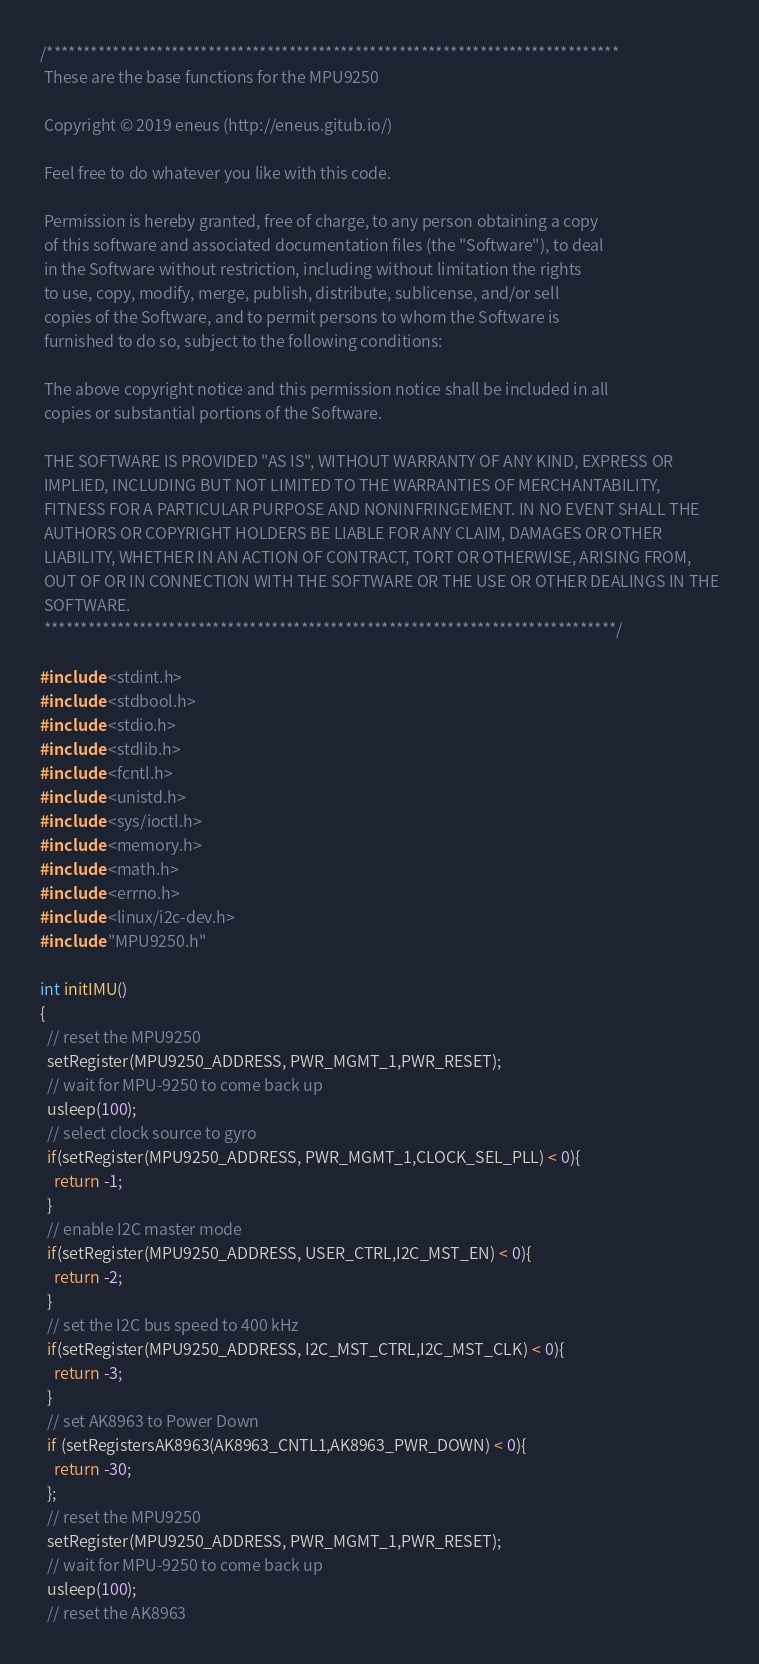Convert code to text. <code><loc_0><loc_0><loc_500><loc_500><_C_>/******************************************************************************
 These are the base functions for the MPU9250

 Copyright © 2019 eneus (http://eneus.gitub.io/)

 Feel free to do whatever you like with this code.

 Permission is hereby granted, free of charge, to any person obtaining a copy
 of this software and associated documentation files (the "Software"), to deal
 in the Software without restriction, including without limitation the rights
 to use, copy, modify, merge, publish, distribute, sublicense, and/or sell
 copies of the Software, and to permit persons to whom the Software is
 furnished to do so, subject to the following conditions:

 The above copyright notice and this permission notice shall be included in all
 copies or substantial portions of the Software.

 THE SOFTWARE IS PROVIDED "AS IS", WITHOUT WARRANTY OF ANY KIND, EXPRESS OR
 IMPLIED, INCLUDING BUT NOT LIMITED TO THE WARRANTIES OF MERCHANTABILITY,
 FITNESS FOR A PARTICULAR PURPOSE AND NONINFRINGEMENT. IN NO EVENT SHALL THE
 AUTHORS OR COPYRIGHT HOLDERS BE LIABLE FOR ANY CLAIM, DAMAGES OR OTHER
 LIABILITY, WHETHER IN AN ACTION OF CONTRACT, TORT OR OTHERWISE, ARISING FROM,
 OUT OF OR IN CONNECTION WITH THE SOFTWARE OR THE USE OR OTHER DEALINGS IN THE
 SOFTWARE.
 ******************************************************************************/

#include <stdint.h>
#include <stdbool.h> 
#include <stdio.h>
#include <stdlib.h>
#include <fcntl.h>
#include <unistd.h>
#include <sys/ioctl.h>
#include <memory.h>
#include <math.h>
#include <errno.h>
#include <linux/i2c-dev.h>
#include "MPU9250.h"

int initIMU()
{
  // reset the MPU9250
  setRegister(MPU9250_ADDRESS, PWR_MGMT_1,PWR_RESET);
  // wait for MPU-9250 to come back up
  usleep(100);
  // select clock source to gyro
  if(setRegister(MPU9250_ADDRESS, PWR_MGMT_1,CLOCK_SEL_PLL) < 0){
    return -1;
  }
  // enable I2C master mode
  if(setRegister(MPU9250_ADDRESS, USER_CTRL,I2C_MST_EN) < 0){
    return -2;
  }
  // set the I2C bus speed to 400 kHz
  if(setRegister(MPU9250_ADDRESS, I2C_MST_CTRL,I2C_MST_CLK) < 0){
    return -3;
  }
  // set AK8963 to Power Down
  if (setRegistersAK8963(AK8963_CNTL1,AK8963_PWR_DOWN) < 0){
    return -30;
  };
  // reset the MPU9250
  setRegister(MPU9250_ADDRESS, PWR_MGMT_1,PWR_RESET);
  // wait for MPU-9250 to come back up
  usleep(100);
  // reset the AK8963</code> 